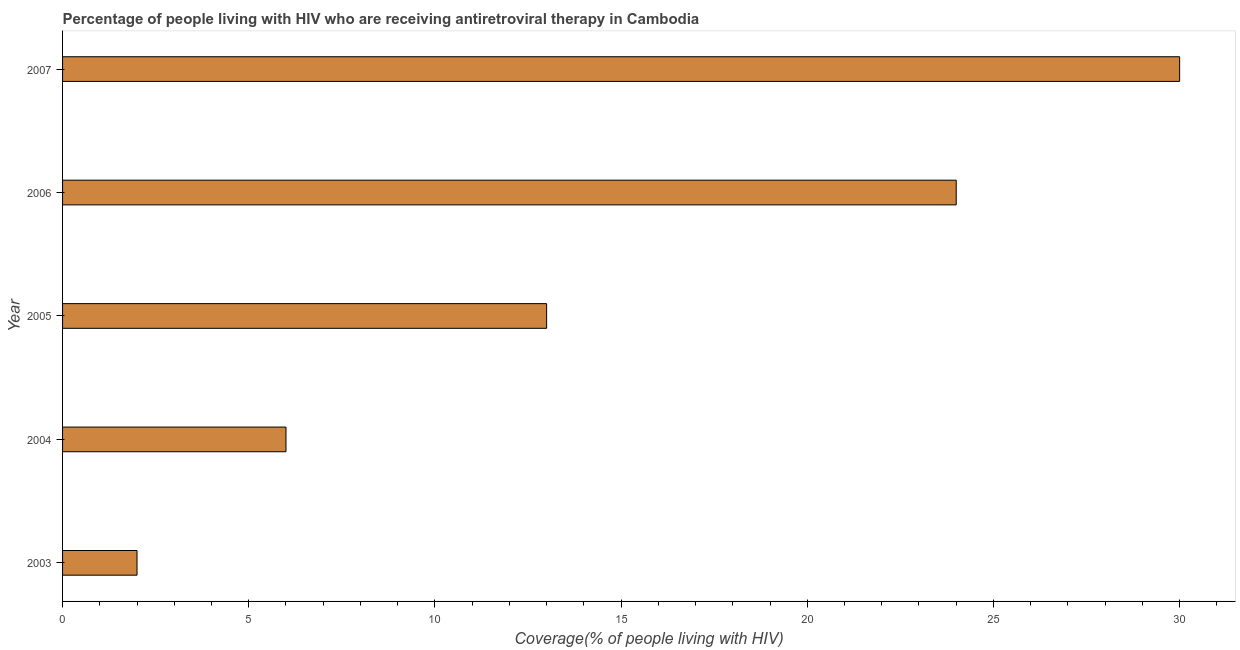Does the graph contain any zero values?
Give a very brief answer. No. Does the graph contain grids?
Offer a very short reply. No. What is the title of the graph?
Your answer should be very brief. Percentage of people living with HIV who are receiving antiretroviral therapy in Cambodia. What is the label or title of the X-axis?
Offer a terse response. Coverage(% of people living with HIV). What is the label or title of the Y-axis?
Provide a short and direct response. Year. Across all years, what is the maximum antiretroviral therapy coverage?
Provide a succinct answer. 30. In which year was the antiretroviral therapy coverage maximum?
Your response must be concise. 2007. What is the average antiretroviral therapy coverage per year?
Your answer should be very brief. 15. What is the median antiretroviral therapy coverage?
Provide a short and direct response. 13. In how many years, is the antiretroviral therapy coverage greater than 3 %?
Your answer should be very brief. 4. Do a majority of the years between 2007 and 2004 (inclusive) have antiretroviral therapy coverage greater than 30 %?
Your answer should be very brief. Yes. What is the ratio of the antiretroviral therapy coverage in 2004 to that in 2005?
Make the answer very short. 0.46. Is the antiretroviral therapy coverage in 2003 less than that in 2005?
Your response must be concise. Yes. Is the difference between the antiretroviral therapy coverage in 2003 and 2006 greater than the difference between any two years?
Offer a very short reply. No. Is the sum of the antiretroviral therapy coverage in 2006 and 2007 greater than the maximum antiretroviral therapy coverage across all years?
Your answer should be very brief. Yes. In how many years, is the antiretroviral therapy coverage greater than the average antiretroviral therapy coverage taken over all years?
Your answer should be very brief. 2. Are the values on the major ticks of X-axis written in scientific E-notation?
Offer a very short reply. No. What is the Coverage(% of people living with HIV) in 2003?
Provide a short and direct response. 2. What is the Coverage(% of people living with HIV) in 2004?
Your response must be concise. 6. What is the Coverage(% of people living with HIV) of 2005?
Your response must be concise. 13. What is the Coverage(% of people living with HIV) of 2007?
Your response must be concise. 30. What is the difference between the Coverage(% of people living with HIV) in 2003 and 2006?
Make the answer very short. -22. What is the difference between the Coverage(% of people living with HIV) in 2003 and 2007?
Make the answer very short. -28. What is the difference between the Coverage(% of people living with HIV) in 2004 and 2005?
Offer a terse response. -7. What is the difference between the Coverage(% of people living with HIV) in 2004 and 2006?
Provide a short and direct response. -18. What is the difference between the Coverage(% of people living with HIV) in 2004 and 2007?
Keep it short and to the point. -24. What is the difference between the Coverage(% of people living with HIV) in 2005 and 2006?
Ensure brevity in your answer.  -11. What is the difference between the Coverage(% of people living with HIV) in 2005 and 2007?
Your response must be concise. -17. What is the ratio of the Coverage(% of people living with HIV) in 2003 to that in 2004?
Ensure brevity in your answer.  0.33. What is the ratio of the Coverage(% of people living with HIV) in 2003 to that in 2005?
Your answer should be compact. 0.15. What is the ratio of the Coverage(% of people living with HIV) in 2003 to that in 2006?
Your response must be concise. 0.08. What is the ratio of the Coverage(% of people living with HIV) in 2003 to that in 2007?
Your answer should be very brief. 0.07. What is the ratio of the Coverage(% of people living with HIV) in 2004 to that in 2005?
Your response must be concise. 0.46. What is the ratio of the Coverage(% of people living with HIV) in 2005 to that in 2006?
Ensure brevity in your answer.  0.54. What is the ratio of the Coverage(% of people living with HIV) in 2005 to that in 2007?
Give a very brief answer. 0.43. What is the ratio of the Coverage(% of people living with HIV) in 2006 to that in 2007?
Offer a very short reply. 0.8. 